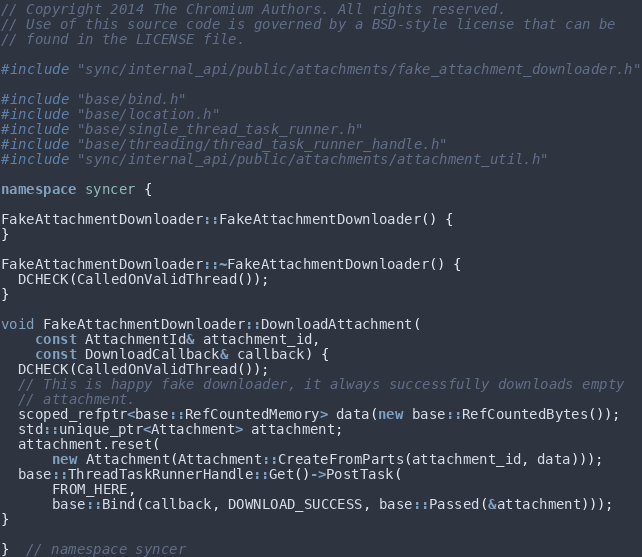<code> <loc_0><loc_0><loc_500><loc_500><_C++_>// Copyright 2014 The Chromium Authors. All rights reserved.
// Use of this source code is governed by a BSD-style license that can be
// found in the LICENSE file.

#include "sync/internal_api/public/attachments/fake_attachment_downloader.h"

#include "base/bind.h"
#include "base/location.h"
#include "base/single_thread_task_runner.h"
#include "base/threading/thread_task_runner_handle.h"
#include "sync/internal_api/public/attachments/attachment_util.h"

namespace syncer {

FakeAttachmentDownloader::FakeAttachmentDownloader() {
}

FakeAttachmentDownloader::~FakeAttachmentDownloader() {
  DCHECK(CalledOnValidThread());
}

void FakeAttachmentDownloader::DownloadAttachment(
    const AttachmentId& attachment_id,
    const DownloadCallback& callback) {
  DCHECK(CalledOnValidThread());
  // This is happy fake downloader, it always successfully downloads empty
  // attachment.
  scoped_refptr<base::RefCountedMemory> data(new base::RefCountedBytes());
  std::unique_ptr<Attachment> attachment;
  attachment.reset(
      new Attachment(Attachment::CreateFromParts(attachment_id, data)));
  base::ThreadTaskRunnerHandle::Get()->PostTask(
      FROM_HERE,
      base::Bind(callback, DOWNLOAD_SUCCESS, base::Passed(&attachment)));
}

}  // namespace syncer
</code> 